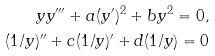Convert formula to latex. <formula><loc_0><loc_0><loc_500><loc_500>y y ^ { \prime \prime \prime } + a ( y ^ { \prime } ) ^ { 2 } + b y ^ { 2 } = 0 , \\ ( 1 / y ) ^ { \prime \prime } + c ( 1 / y ) ^ { \prime } + d ( 1 / y ) = 0</formula> 